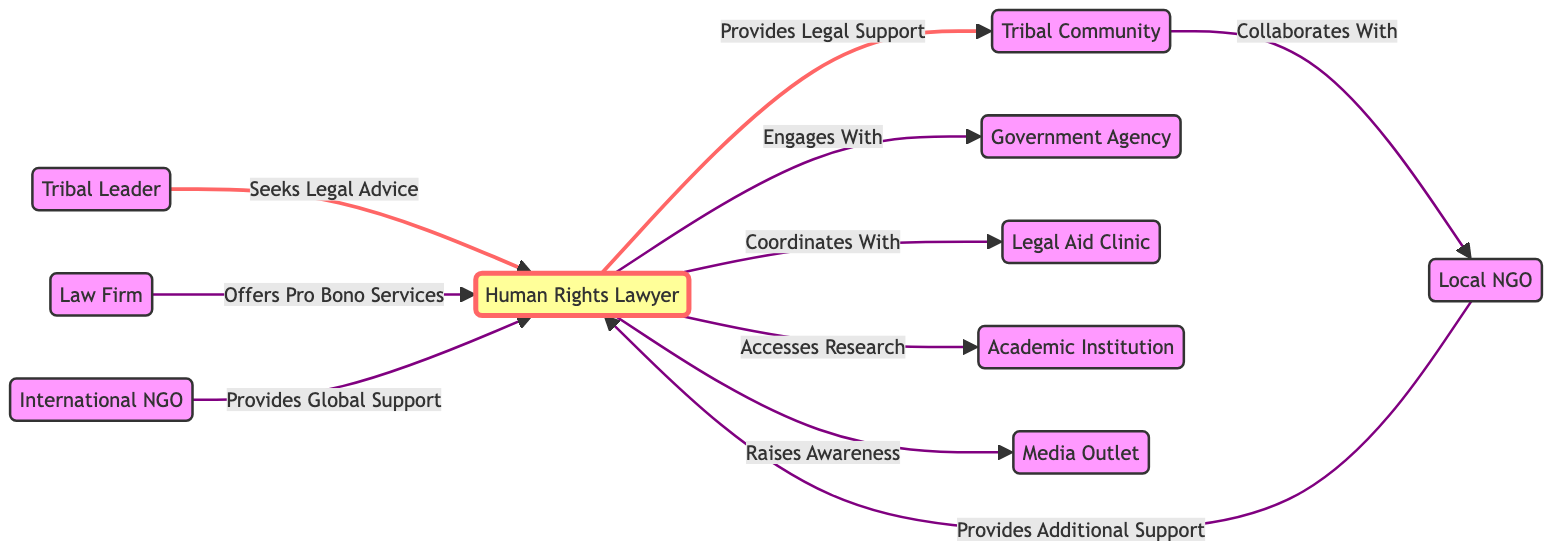What is the total number of nodes in the diagram? The diagram lists multiple entities, which are represented as nodes. By counting each individual node, we find a total of 10 distinct entries: Tribal Leader, Human Rights Lawyer, Tribal Community, Local NGO, Government Agency, Legal Aid Clinic, Law Firm, Academic Institution, Media Outlet, and International NGO.
Answer: 10 Who seeks legal advice in the diagram? The relationship directed from the Tribal Leader indicates that this entity is the one asking for legal guidance. The edge labeled "Seeks Legal Advice" clearly shows the direction from the Tribal Leader to the Human Rights Lawyer.
Answer: Tribal Leader What does the Human Rights Lawyer provide to the Tribal Community? The edge labeled "Provides Legal Support" connects the Human Rights Lawyer directly to the Tribal Community, indicating the specific type of assistance being provided.
Answer: Legal Support Which organizations collaborate with the Tribal Community? The directed edge from the Tribal Community to the Local NGO, labeled "Collaborates With," indicates that the Local NGO is the organization that has this collaborative relationship.
Answer: Local NGO What type of services does the Law Firm offer to the Human Rights Lawyer? The diagram includes an edge labeled "Offers Pro Bono Services" directed from the Law Firm to the Human Rights Lawyer, clearly indicating the nature of the support provided.
Answer: Pro Bono Services How many entities directly interact with the Human Rights Lawyer? Analyzing the outgoing edges from the Human Rights Lawyer, we find that there are six interactions: with the Tribal Community, Government Agency, Legal Aid Clinic, Local NGO, Media Outlet, and International NGO. Hence, counting these connections gives us the total number of entities interacting with the Human Rights Lawyer.
Answer: 6 What type of support does the International NGO provide? The edge labeled "Provides Global Support" directly connects the International NGO to the Human Rights Lawyer, which specifies the nature of the support provided in the context of international help.
Answer: Global Support Which node coordinates with the Legal Aid Clinic? The directed edge labeled "Coordinates With" indicates that the Human Rights Lawyer is the node engaging with the Legal Aid Clinic. Thus, we identify the coordinating entity by following this path.
Answer: Human Rights Lawyer What role does the Media Outlet play in the network? The edge directed from the Human Rights Lawyer to the Media Outlet, labeled "Raises Awareness," shows that the Media Outlet plays a role in disseminating information or advocacy efforts intended to increase public awareness about issues relating to tribal communities.
Answer: Raises Awareness 